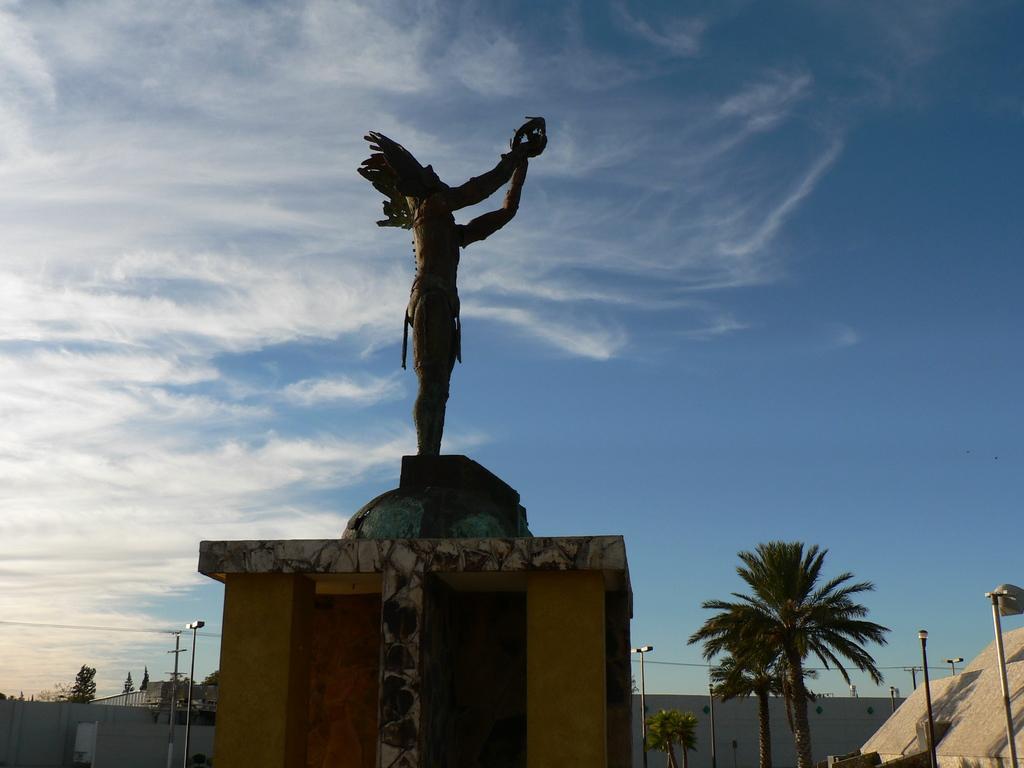Could you give a brief overview of what you see in this image? In this image I can see a statute. I can see trees,light-poles and wall. The sky is in white and blue color. 